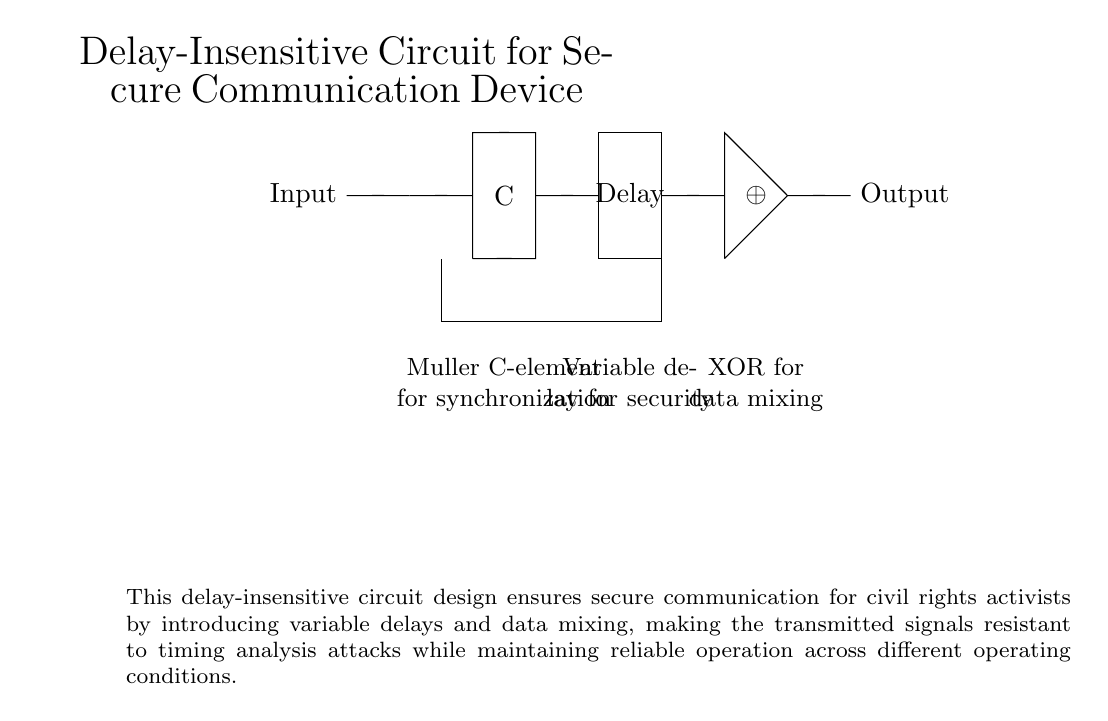What is the main function of the Muller C-element in this circuit? The Muller C-element serves as a synchronization component, ensuring that the output reflects the input only when certain conditions are met. It effectively handles varying signal propagation delays, making it suitable for asynchronous circuits.
Answer: Synchronization What component introduces variable delay into the circuit? The component that introduces variable delay is explicitly labeled as "Delay" in the circuit diagram. This element is designed to complicate timing analysis by offering unpredictable signal delays.
Answer: Delay How many primary elements are used in this circuit design? The circuit consists of three primary elements: the Muller C-element, the delay element, and the XOR gate. This simplified structure is tailored for secure communication.
Answer: Three What does the XOR gate do in this circuit? The XOR gate is used for data mixing, meaning it combines input signals in a way that adds complexity to the output, making it more secure against analysis.
Answer: Data mixing Why is the delay element critical for secure communication? The delay element is essential because it introduces unpredictability in the timing of the signals, making the circuit less vulnerable to timing analysis attacks while maintaining functionality.
Answer: Security What type of circuit is demonstrated in the diagram? This circuit is an asynchronous circuit, characterized by the absence of a global clock and instead relying on local signal transitions for operation.
Answer: Asynchronous What is the role of the feedback loop in the circuit? The feedback loop assists in maintaining conditions necessary for the stable operation of the Muller C-element, ensuring that the output will change only when necessary and adding to the overall reliability of the communication system.
Answer: Stability 